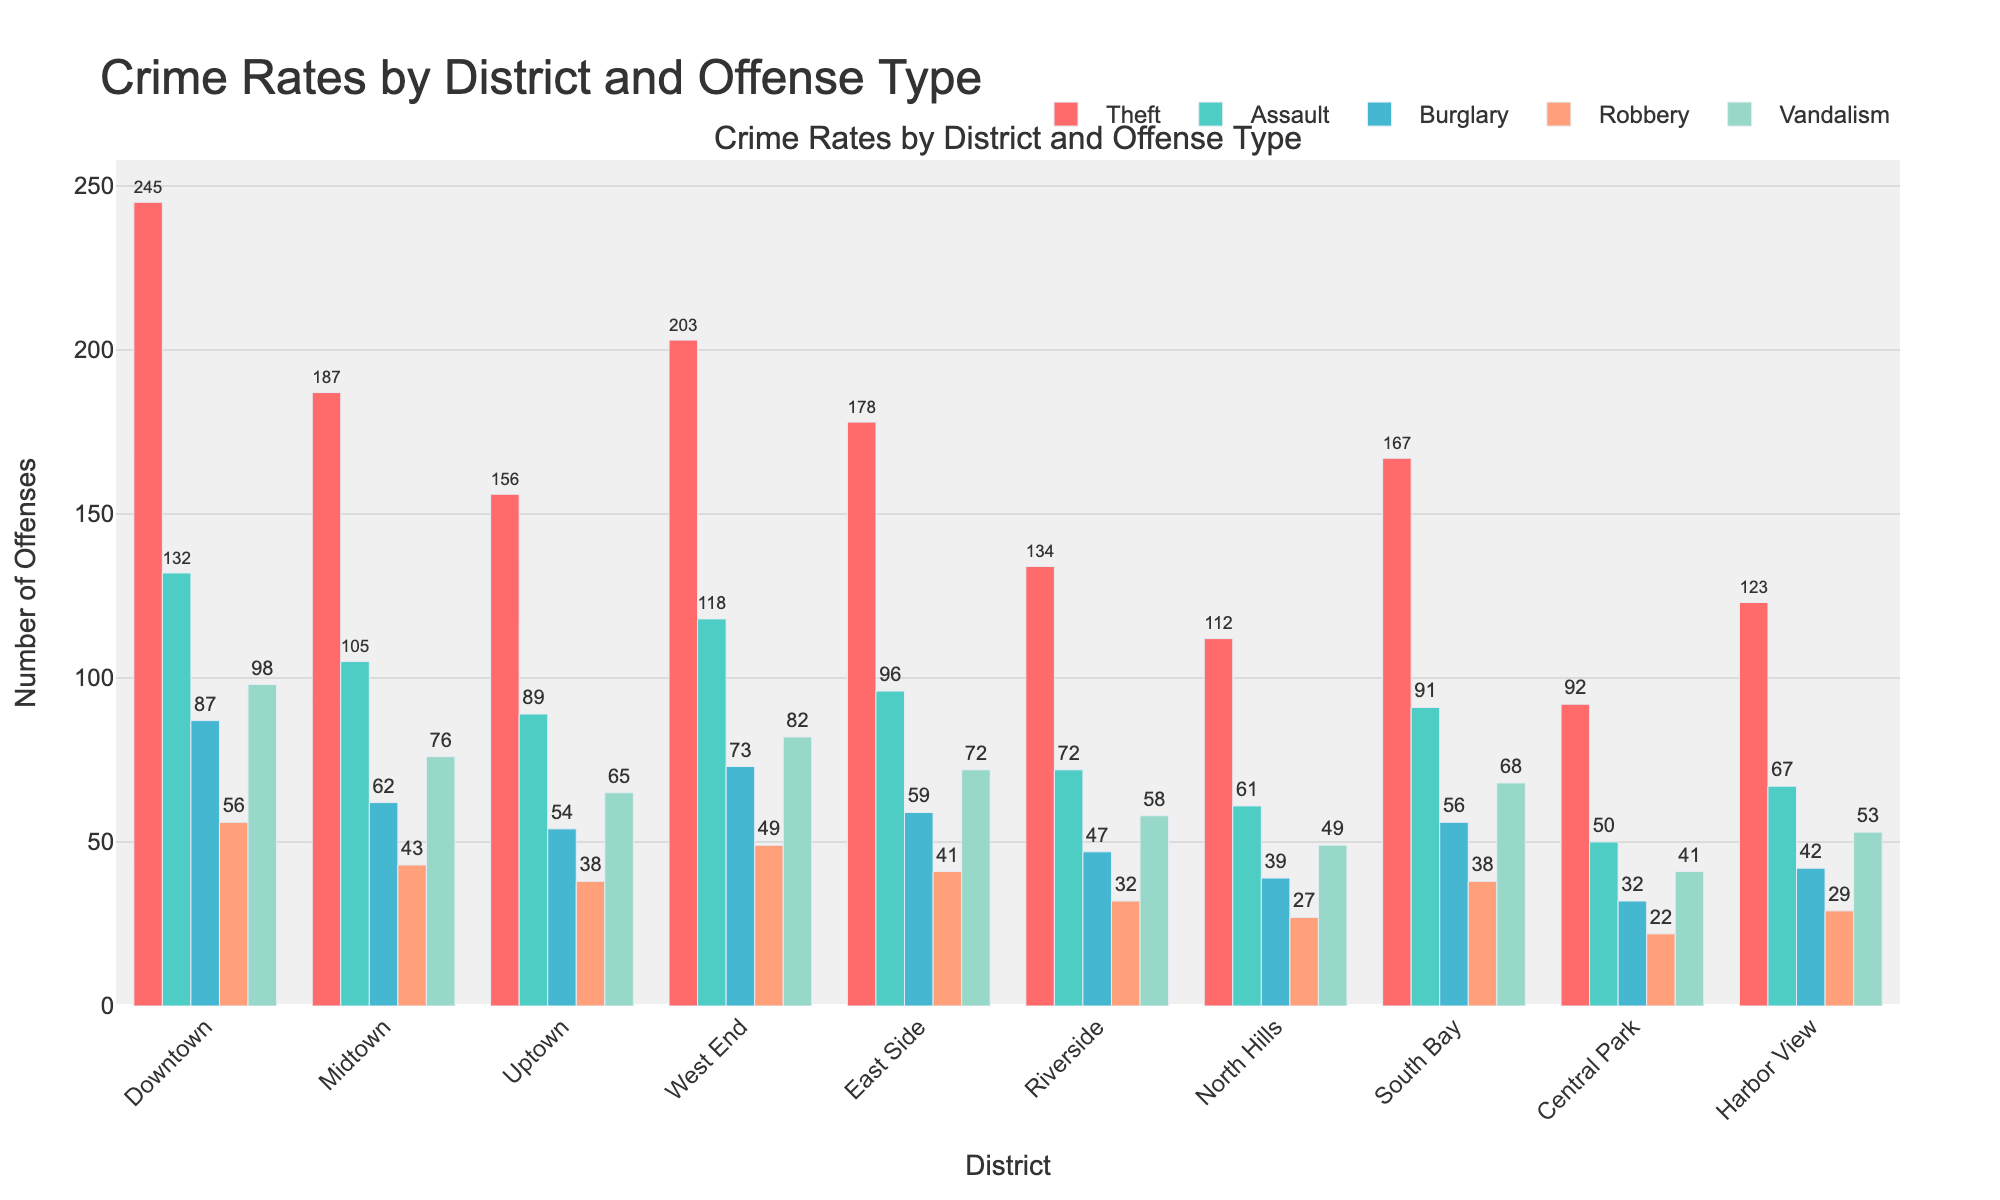What's the total number of Thefts in all districts combined? To find the total number of Thefts in all districts, we add the number of Thefts in each district: 245 (Downtown) + 187 (Midtown) + 156 (Uptown) + 203 (West End) + 178 (East Side) + 134 (Riverside) + 112 (North Hills) + 167 (South Bay) + 92 (Central Park) + 123 (Harbor View) = 1597
Answer: 1597 Which district has the highest number of Burglaries? By comparing the height of the bars representing Burglaries across all districts, we see that Downtown has the highest bar for Burglaries with a value of 87.
Answer: Downtown What is the difference in the number of Assaults between Downtown and Riverside? To find the difference, subtract the number of Assaults in Riverside from the number in Downtown: 132 (Downtown) - 72 (Riverside) = 60
Answer: 60 Which offense type has the lowest reported incidents in Midtown? By looking at the height of the bars for different offense types in Midtown, we see that Robbery has the lowest value with 43 incidents.
Answer: Robbery What's the average number of Vandalism incidents across all districts? To find the average number of Vandalism incidents, we sum up the Vandalism incidents for all districts and divide by the number of districts: (98 + 76 + 65 + 82 + 72 + 58 + 49 + 68 + 41 + 53) / 10 = 662 / 10 = 66.2
Answer: 66.2 Are there more Robberies or Burglaries in Uptown? By comparing the heights of the bars for Robberies and Burglaries in Uptown, we see that there are 54 Burglaries and 38 Robberies. Therefore, there are more Burglaries than Robberies in Uptown.
Answer: Burglaries How many total Assaults were reported in all districts except Central Park? To find the total, we sum the number of Assaults in all districts except Central Park: 132 + 105 + 89 + 118 + 96 + 72 + 61 + 91 + 67 (excluding 50 from Central Park) = 731
Answer: 731 What is the combined number of Thefts and Robberies in West End? Adding the values for Thefts and Robberies in West End: 203 (Theft) + 49 (Robbery) = 252
Answer: 252 In which district is the difference between the number of Burglary and Robbery incidents the smallest? By calculating the absolute difference for each district: Downtown (87-56=31), Midtown (62-43=19), Uptown (54-38=16), West End (73-49=24), East Side (59-41=18), Riverside (47-32=15), North Hills (39-27=12), South Bay (56-38=18), Central Park (32-22=10), Harbor View (42-29=13). Central Park has the smallest difference with a value of 10.
Answer: Central Park Which district has the highest number of total crime incidents? To determine the district with the highest total crime incidents, sum the values for each district and compare: Downtown (618), Midtown (473), Uptown (402), West End (525), East Side (446), Riverside (343), North Hills (288), South Bay (420), Central Park (237), Harbor View (314). Downtown has the highest total with 618 incidents.
Answer: Downtown 